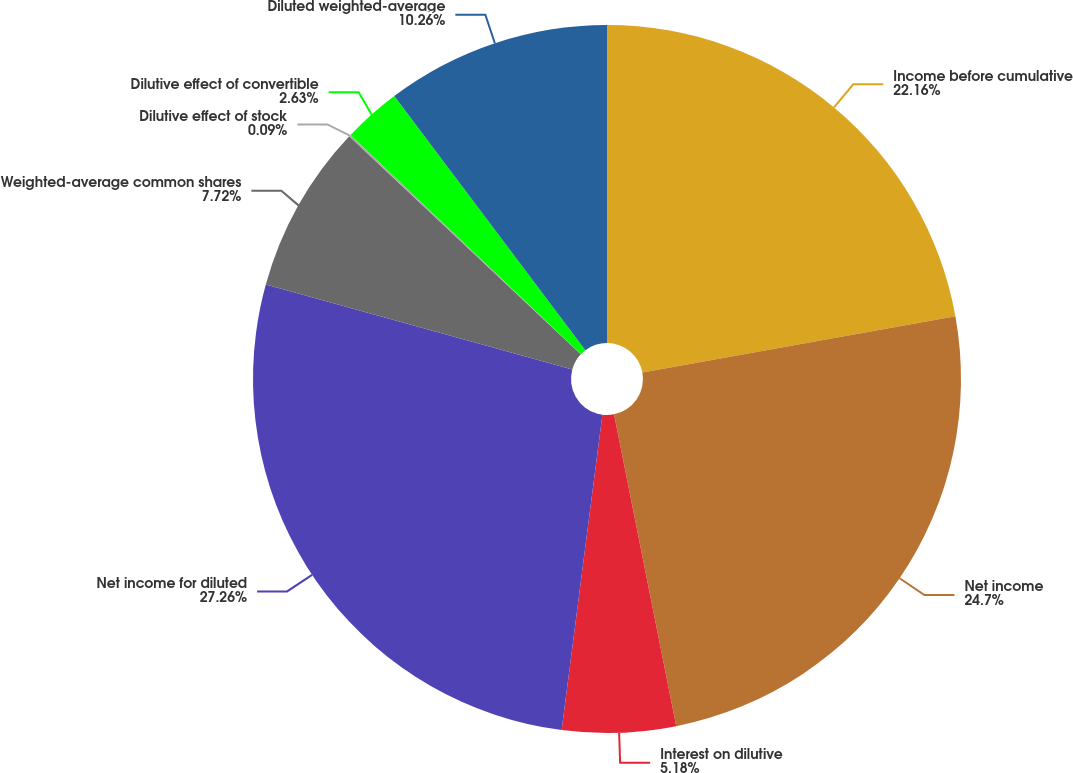Convert chart. <chart><loc_0><loc_0><loc_500><loc_500><pie_chart><fcel>Income before cumulative<fcel>Net income<fcel>Interest on dilutive<fcel>Net income for diluted<fcel>Weighted-average common shares<fcel>Dilutive effect of stock<fcel>Dilutive effect of convertible<fcel>Diluted weighted-average<nl><fcel>22.16%<fcel>24.7%<fcel>5.18%<fcel>27.25%<fcel>7.72%<fcel>0.09%<fcel>2.63%<fcel>10.26%<nl></chart> 